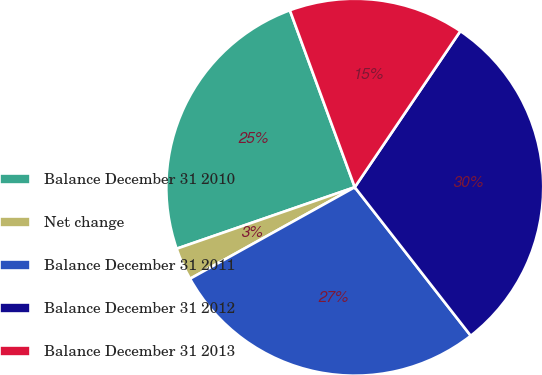Convert chart to OTSL. <chart><loc_0><loc_0><loc_500><loc_500><pie_chart><fcel>Balance December 31 2010<fcel>Net change<fcel>Balance December 31 2011<fcel>Balance December 31 2012<fcel>Balance December 31 2013<nl><fcel>24.7%<fcel>2.78%<fcel>27.48%<fcel>29.99%<fcel>15.06%<nl></chart> 